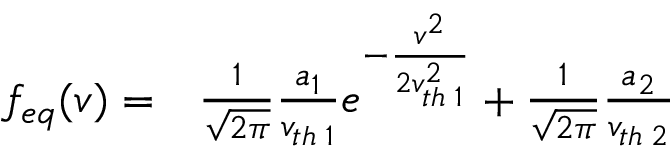Convert formula to latex. <formula><loc_0><loc_0><loc_500><loc_500>\begin{array} { r l } { f _ { e q } ( v ) = } & \frac { 1 } { \sqrt { 2 \pi } } \frac { a _ { 1 } } { v _ { t h \, 1 } } e ^ { - \frac { v ^ { 2 } } { 2 v _ { t h \, 1 } ^ { 2 } } } + \frac { 1 } { \sqrt { 2 \pi } } \frac { a _ { 2 } } { v _ { t h \, 2 } } } \end{array}</formula> 